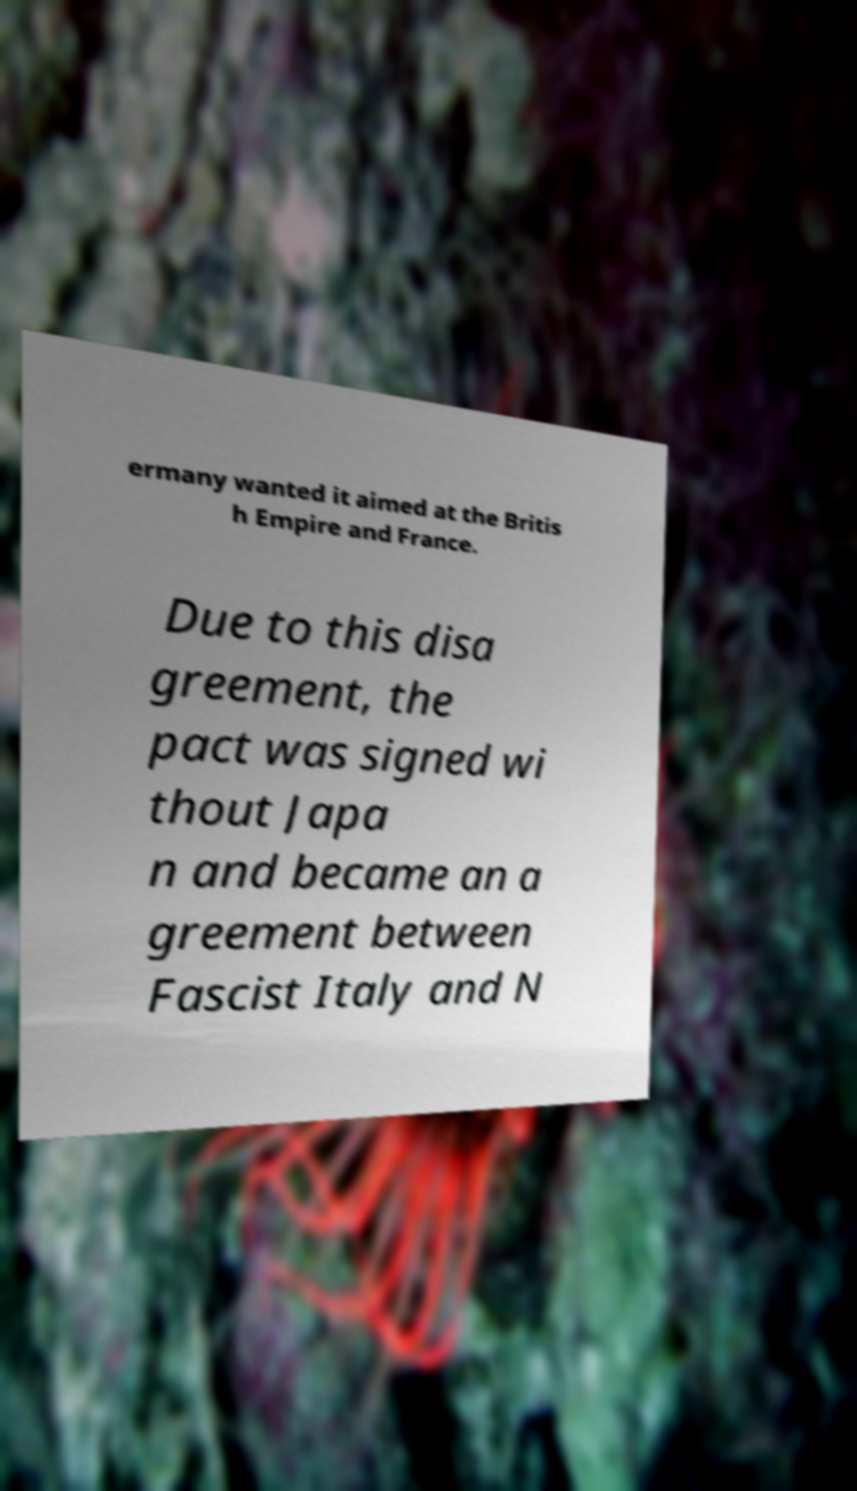What messages or text are displayed in this image? I need them in a readable, typed format. ermany wanted it aimed at the Britis h Empire and France. Due to this disa greement, the pact was signed wi thout Japa n and became an a greement between Fascist Italy and N 